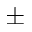Convert formula to latex. <formula><loc_0><loc_0><loc_500><loc_500>\pm</formula> 